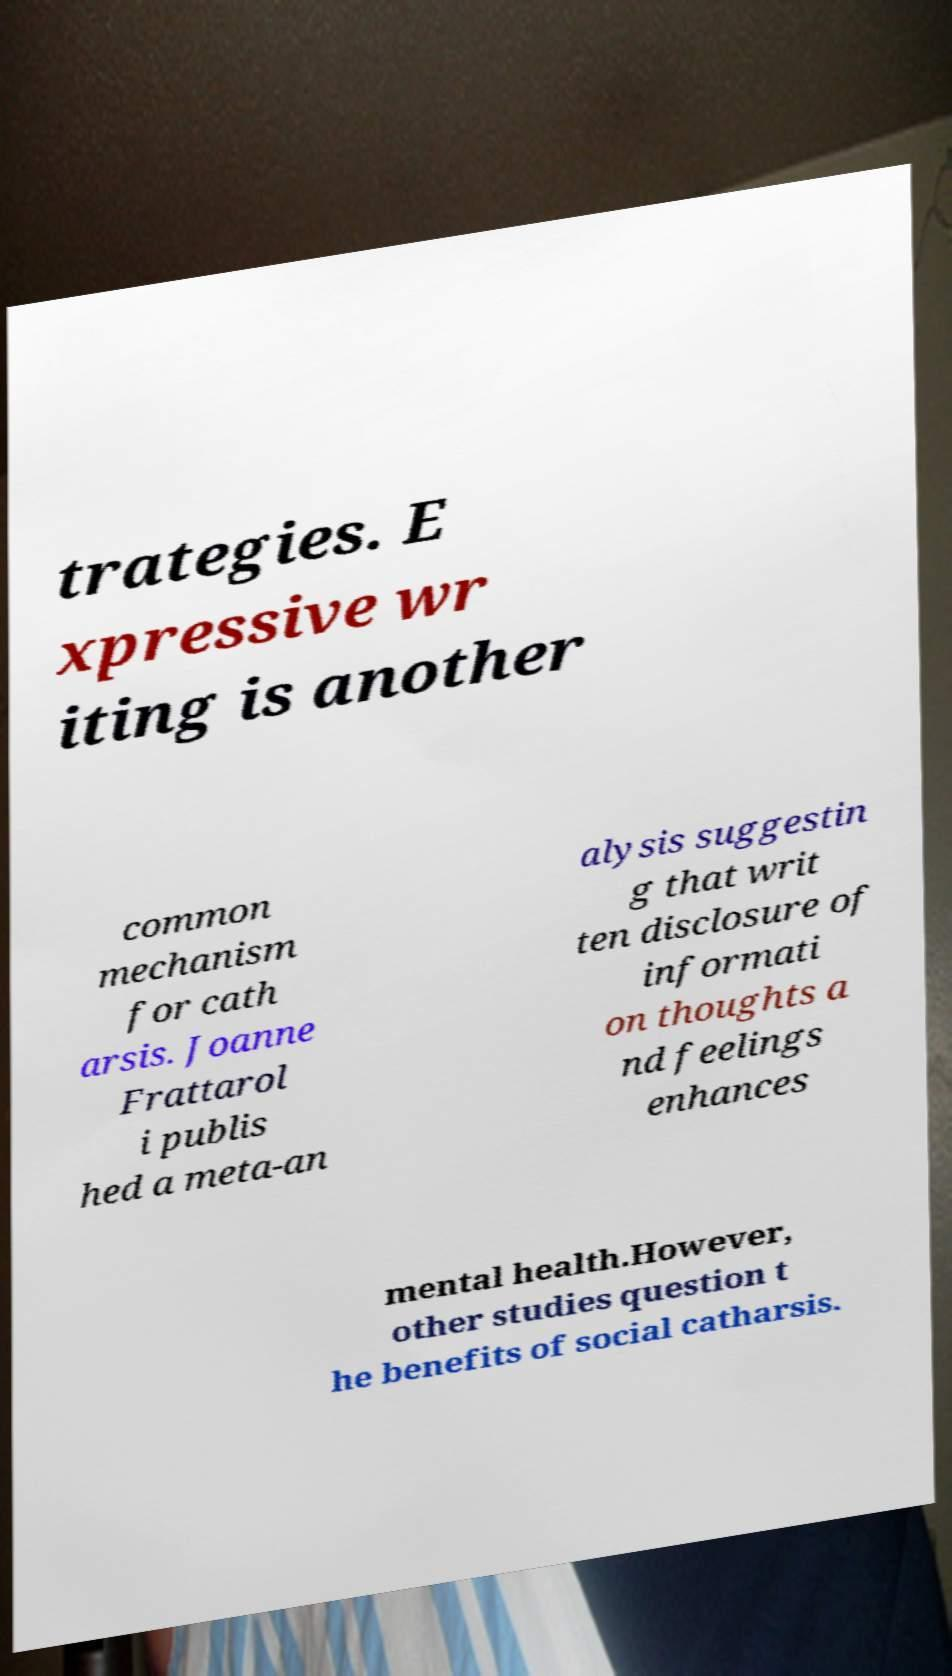Can you read and provide the text displayed in the image?This photo seems to have some interesting text. Can you extract and type it out for me? trategies. E xpressive wr iting is another common mechanism for cath arsis. Joanne Frattarol i publis hed a meta-an alysis suggestin g that writ ten disclosure of informati on thoughts a nd feelings enhances mental health.However, other studies question t he benefits of social catharsis. 